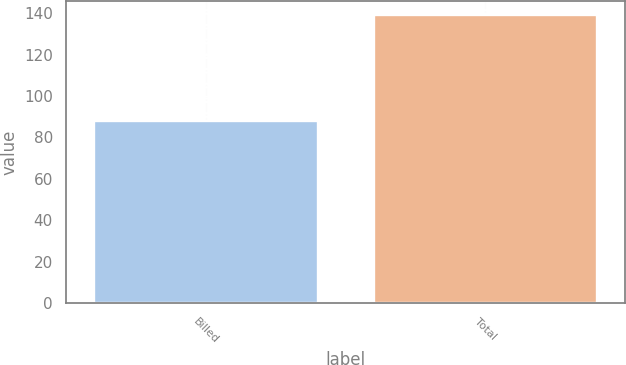Convert chart to OTSL. <chart><loc_0><loc_0><loc_500><loc_500><bar_chart><fcel>Billed<fcel>Total<nl><fcel>88<fcel>139<nl></chart> 